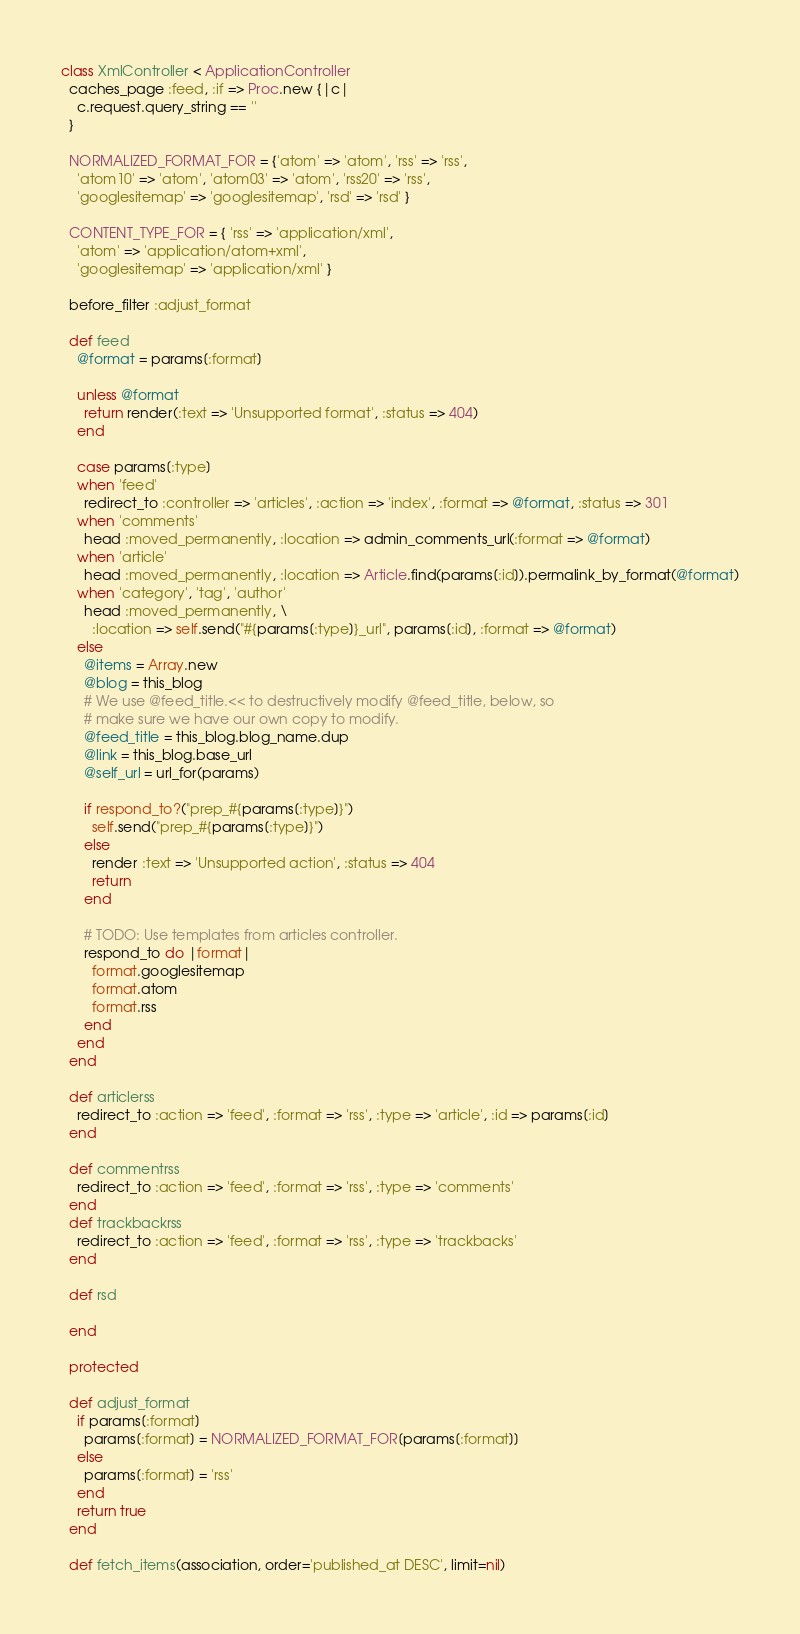<code> <loc_0><loc_0><loc_500><loc_500><_Ruby_>class XmlController < ApplicationController
  caches_page :feed, :if => Proc.new {|c|
    c.request.query_string == ''
  }

  NORMALIZED_FORMAT_FOR = {'atom' => 'atom', 'rss' => 'rss',
    'atom10' => 'atom', 'atom03' => 'atom', 'rss20' => 'rss',
    'googlesitemap' => 'googlesitemap', 'rsd' => 'rsd' }

  CONTENT_TYPE_FOR = { 'rss' => 'application/xml',
    'atom' => 'application/atom+xml',
    'googlesitemap' => 'application/xml' }

  before_filter :adjust_format

  def feed
    @format = params[:format]

    unless @format
      return render(:text => 'Unsupported format', :status => 404)
    end

    case params[:type]
    when 'feed'
      redirect_to :controller => 'articles', :action => 'index', :format => @format, :status => 301
    when 'comments'
      head :moved_permanently, :location => admin_comments_url(:format => @format)
    when 'article'
      head :moved_permanently, :location => Article.find(params[:id]).permalink_by_format(@format)
    when 'category', 'tag', 'author'
      head :moved_permanently, \
        :location => self.send("#{params[:type]}_url", params[:id], :format => @format)
    else
      @items = Array.new
      @blog = this_blog
      # We use @feed_title.<< to destructively modify @feed_title, below, so
      # make sure we have our own copy to modify.
      @feed_title = this_blog.blog_name.dup
      @link = this_blog.base_url
      @self_url = url_for(params)

      if respond_to?("prep_#{params[:type]}")
        self.send("prep_#{params[:type]}")
      else
        render :text => 'Unsupported action', :status => 404
        return
      end

      # TODO: Use templates from articles controller.
      respond_to do |format|
        format.googlesitemap
        format.atom
        format.rss
      end
    end
  end

  def articlerss
    redirect_to :action => 'feed', :format => 'rss', :type => 'article', :id => params[:id]
  end

  def commentrss
    redirect_to :action => 'feed', :format => 'rss', :type => 'comments'
  end
  def trackbackrss
    redirect_to :action => 'feed', :format => 'rss', :type => 'trackbacks'
  end

  def rsd

  end

  protected

  def adjust_format
    if params[:format]
      params[:format] = NORMALIZED_FORMAT_FOR[params[:format]]
    else
      params[:format] = 'rss'
    end
    return true
  end

  def fetch_items(association, order='published_at DESC', limit=nil)</code> 